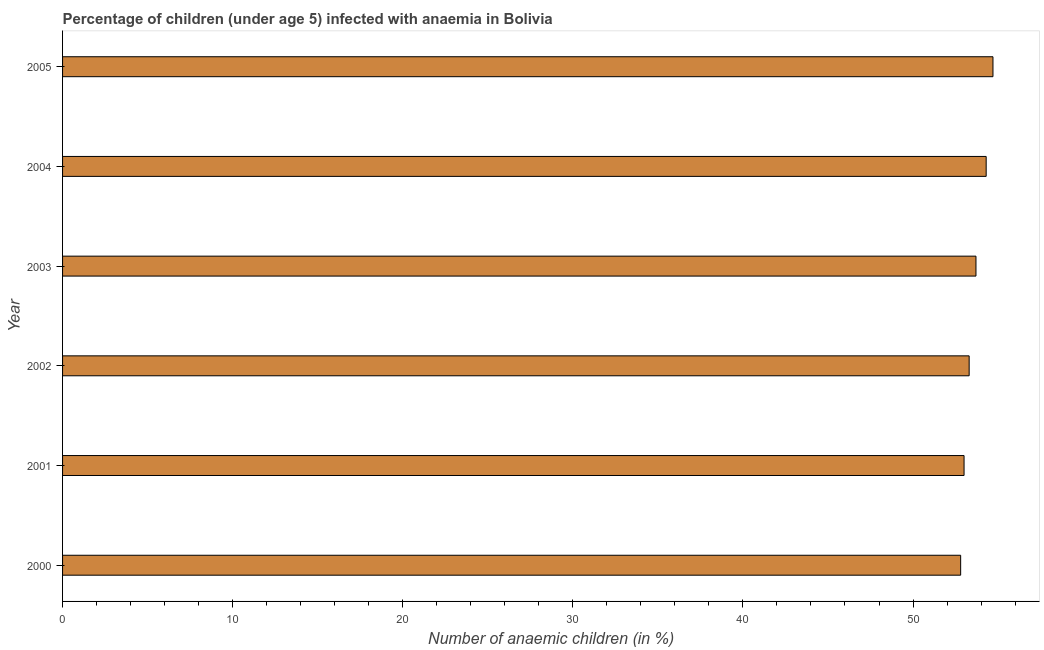What is the title of the graph?
Your response must be concise. Percentage of children (under age 5) infected with anaemia in Bolivia. What is the label or title of the X-axis?
Your answer should be very brief. Number of anaemic children (in %). What is the label or title of the Y-axis?
Ensure brevity in your answer.  Year. What is the number of anaemic children in 2000?
Your response must be concise. 52.8. Across all years, what is the maximum number of anaemic children?
Keep it short and to the point. 54.7. Across all years, what is the minimum number of anaemic children?
Give a very brief answer. 52.8. What is the sum of the number of anaemic children?
Keep it short and to the point. 321.8. What is the average number of anaemic children per year?
Provide a succinct answer. 53.63. What is the median number of anaemic children?
Give a very brief answer. 53.5. Do a majority of the years between 2002 and 2003 (inclusive) have number of anaemic children greater than 36 %?
Your answer should be very brief. Yes. What is the ratio of the number of anaemic children in 2002 to that in 2005?
Provide a succinct answer. 0.97. Is the difference between the number of anaemic children in 2000 and 2002 greater than the difference between any two years?
Offer a very short reply. No. What is the difference between the highest and the second highest number of anaemic children?
Make the answer very short. 0.4. In how many years, is the number of anaemic children greater than the average number of anaemic children taken over all years?
Your response must be concise. 3. How many bars are there?
Keep it short and to the point. 6. Are all the bars in the graph horizontal?
Offer a terse response. Yes. How many years are there in the graph?
Make the answer very short. 6. What is the difference between two consecutive major ticks on the X-axis?
Your answer should be very brief. 10. What is the Number of anaemic children (in %) of 2000?
Offer a very short reply. 52.8. What is the Number of anaemic children (in %) of 2001?
Provide a succinct answer. 53. What is the Number of anaemic children (in %) of 2002?
Offer a terse response. 53.3. What is the Number of anaemic children (in %) in 2003?
Provide a succinct answer. 53.7. What is the Number of anaemic children (in %) in 2004?
Offer a very short reply. 54.3. What is the Number of anaemic children (in %) in 2005?
Offer a terse response. 54.7. What is the difference between the Number of anaemic children (in %) in 2000 and 2001?
Make the answer very short. -0.2. What is the difference between the Number of anaemic children (in %) in 2000 and 2004?
Offer a terse response. -1.5. What is the difference between the Number of anaemic children (in %) in 2001 and 2003?
Keep it short and to the point. -0.7. What is the difference between the Number of anaemic children (in %) in 2002 and 2003?
Make the answer very short. -0.4. What is the difference between the Number of anaemic children (in %) in 2002 and 2005?
Your answer should be very brief. -1.4. What is the difference between the Number of anaemic children (in %) in 2003 and 2004?
Offer a terse response. -0.6. What is the difference between the Number of anaemic children (in %) in 2003 and 2005?
Your answer should be compact. -1. What is the difference between the Number of anaemic children (in %) in 2004 and 2005?
Provide a succinct answer. -0.4. What is the ratio of the Number of anaemic children (in %) in 2000 to that in 2004?
Your response must be concise. 0.97. What is the ratio of the Number of anaemic children (in %) in 2000 to that in 2005?
Your answer should be compact. 0.96. What is the ratio of the Number of anaemic children (in %) in 2001 to that in 2002?
Make the answer very short. 0.99. What is the ratio of the Number of anaemic children (in %) in 2001 to that in 2004?
Your response must be concise. 0.98. What is the ratio of the Number of anaemic children (in %) in 2002 to that in 2003?
Make the answer very short. 0.99. What is the ratio of the Number of anaemic children (in %) in 2002 to that in 2005?
Your answer should be compact. 0.97. What is the ratio of the Number of anaemic children (in %) in 2003 to that in 2005?
Your answer should be very brief. 0.98. What is the ratio of the Number of anaemic children (in %) in 2004 to that in 2005?
Give a very brief answer. 0.99. 